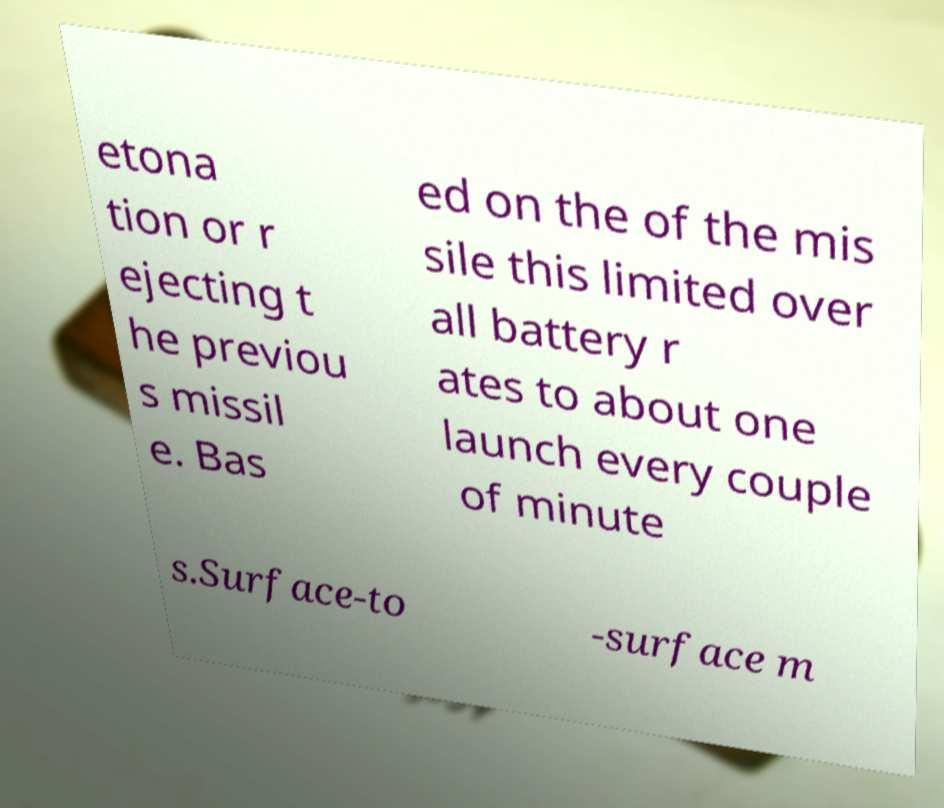Can you accurately transcribe the text from the provided image for me? etona tion or r ejecting t he previou s missil e. Bas ed on the of the mis sile this limited over all battery r ates to about one launch every couple of minute s.Surface-to -surface m 